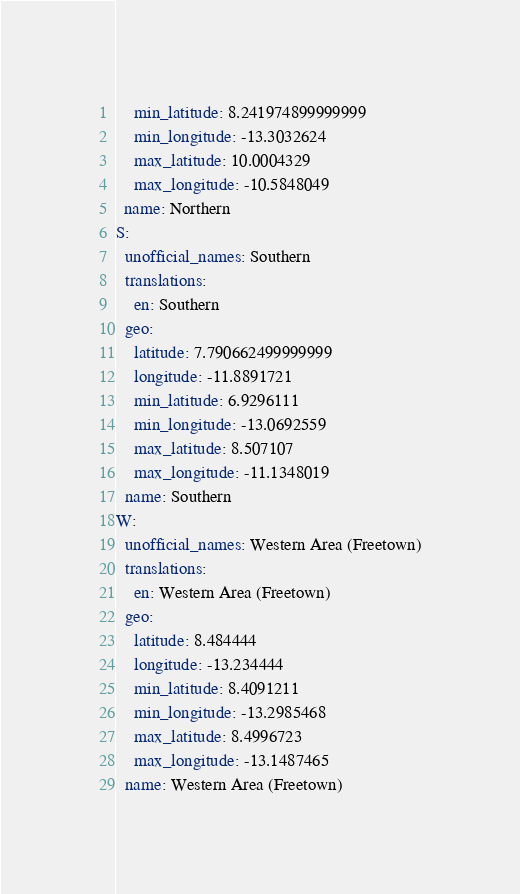<code> <loc_0><loc_0><loc_500><loc_500><_YAML_>    min_latitude: 8.241974899999999
    min_longitude: -13.3032624
    max_latitude: 10.0004329
    max_longitude: -10.5848049
  name: Northern
S:
  unofficial_names: Southern
  translations:
    en: Southern
  geo:
    latitude: 7.790662499999999
    longitude: -11.8891721
    min_latitude: 6.9296111
    min_longitude: -13.0692559
    max_latitude: 8.507107
    max_longitude: -11.1348019
  name: Southern
W:
  unofficial_names: Western Area (Freetown)
  translations:
    en: Western Area (Freetown)
  geo:
    latitude: 8.484444
    longitude: -13.234444
    min_latitude: 8.4091211
    min_longitude: -13.2985468
    max_latitude: 8.4996723
    max_longitude: -13.1487465
  name: Western Area (Freetown)
</code> 